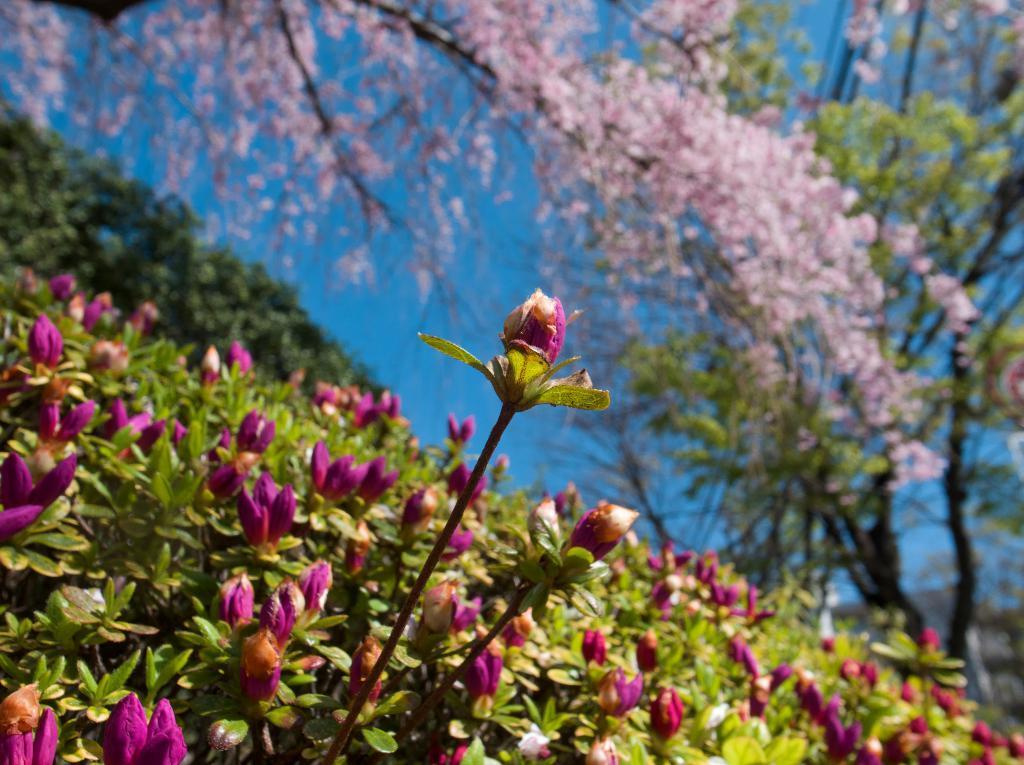Could you give a brief overview of what you see in this image? This image is taken outdoors. At the bottom of the image there are a few plants with flowers. In the background there are a few trees and there is a sky. 